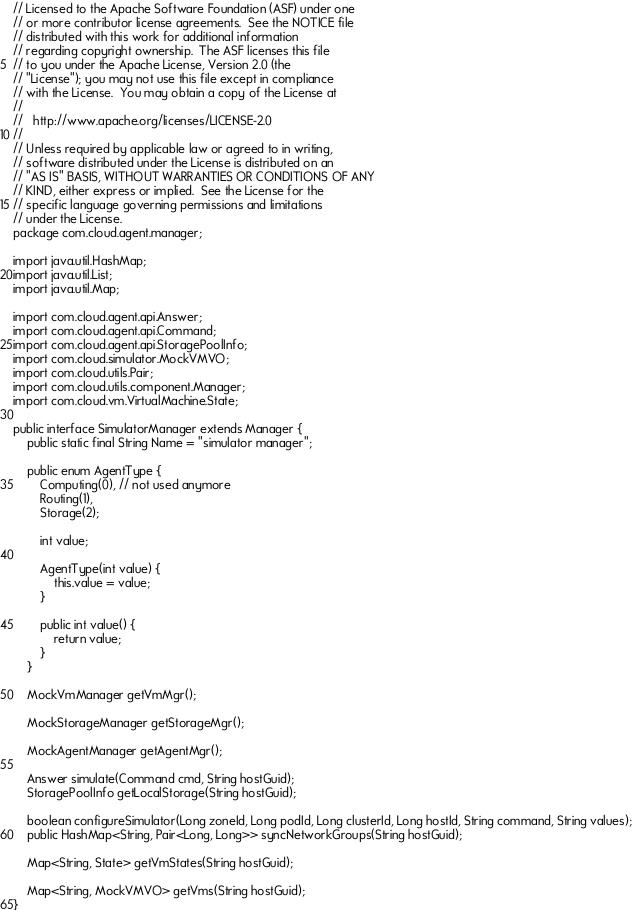Convert code to text. <code><loc_0><loc_0><loc_500><loc_500><_Java_>// Licensed to the Apache Software Foundation (ASF) under one
// or more contributor license agreements.  See the NOTICE file
// distributed with this work for additional information
// regarding copyright ownership.  The ASF licenses this file
// to you under the Apache License, Version 2.0 (the
// "License"); you may not use this file except in compliance
// with the License.  You may obtain a copy of the License at
//
//   http://www.apache.org/licenses/LICENSE-2.0
//
// Unless required by applicable law or agreed to in writing,
// software distributed under the License is distributed on an
// "AS IS" BASIS, WITHOUT WARRANTIES OR CONDITIONS OF ANY
// KIND, either express or implied.  See the License for the
// specific language governing permissions and limitations
// under the License.
package com.cloud.agent.manager;

import java.util.HashMap;
import java.util.List;
import java.util.Map;

import com.cloud.agent.api.Answer;
import com.cloud.agent.api.Command;
import com.cloud.agent.api.StoragePoolInfo;
import com.cloud.simulator.MockVMVO;
import com.cloud.utils.Pair;
import com.cloud.utils.component.Manager;
import com.cloud.vm.VirtualMachine.State;

public interface SimulatorManager extends Manager {
	public static final String Name = "simulator manager";

	public enum AgentType {
		Computing(0), // not used anymore
		Routing(1),
		Storage(2);

		int value;

		AgentType(int value) {
			this.value = value;
		}

		public int value() {
			return value;
		}
	}

    MockVmManager getVmMgr();

    MockStorageManager getStorageMgr();

    MockAgentManager getAgentMgr();

    Answer simulate(Command cmd, String hostGuid);
    StoragePoolInfo getLocalStorage(String hostGuid);

    boolean configureSimulator(Long zoneId, Long podId, Long clusterId, Long hostId, String command, String values);
    public HashMap<String, Pair<Long, Long>> syncNetworkGroups(String hostGuid);

    Map<String, State> getVmStates(String hostGuid);

	Map<String, MockVMVO> getVms(String hostGuid);
}</code> 